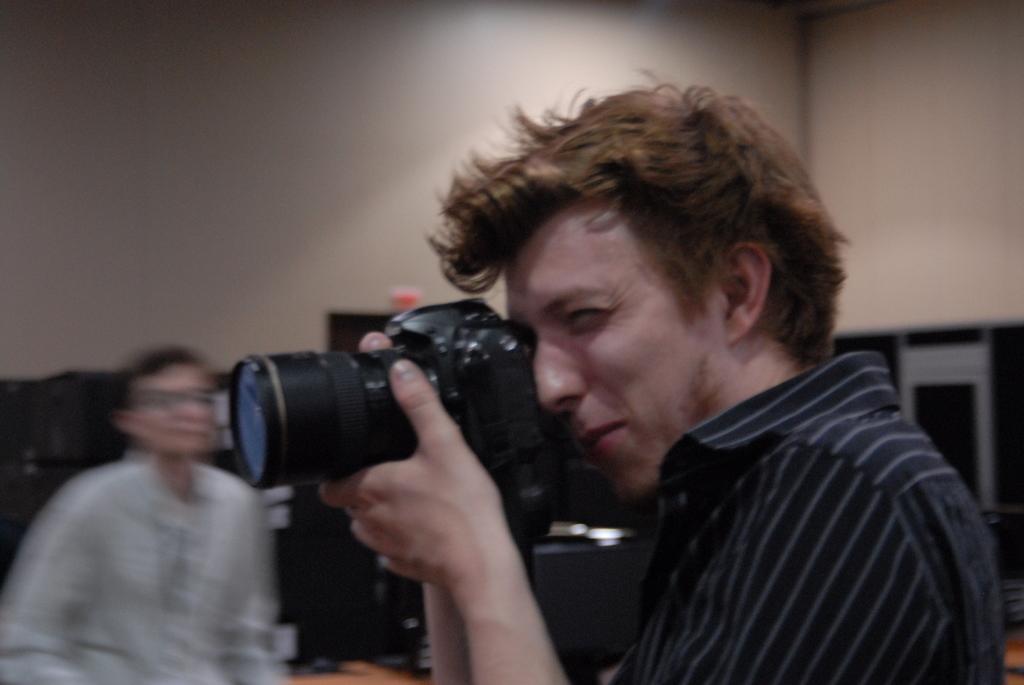How would you summarize this image in a sentence or two? In this image there is a person wearing black color T-shirt holding a camera in his hands. 